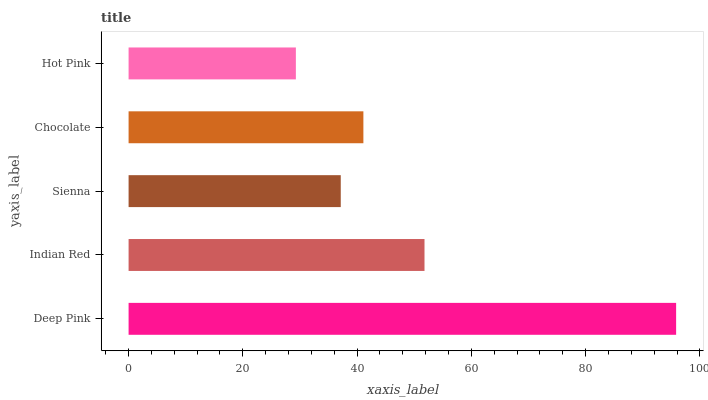Is Hot Pink the minimum?
Answer yes or no. Yes. Is Deep Pink the maximum?
Answer yes or no. Yes. Is Indian Red the minimum?
Answer yes or no. No. Is Indian Red the maximum?
Answer yes or no. No. Is Deep Pink greater than Indian Red?
Answer yes or no. Yes. Is Indian Red less than Deep Pink?
Answer yes or no. Yes. Is Indian Red greater than Deep Pink?
Answer yes or no. No. Is Deep Pink less than Indian Red?
Answer yes or no. No. Is Chocolate the high median?
Answer yes or no. Yes. Is Chocolate the low median?
Answer yes or no. Yes. Is Sienna the high median?
Answer yes or no. No. Is Indian Red the low median?
Answer yes or no. No. 